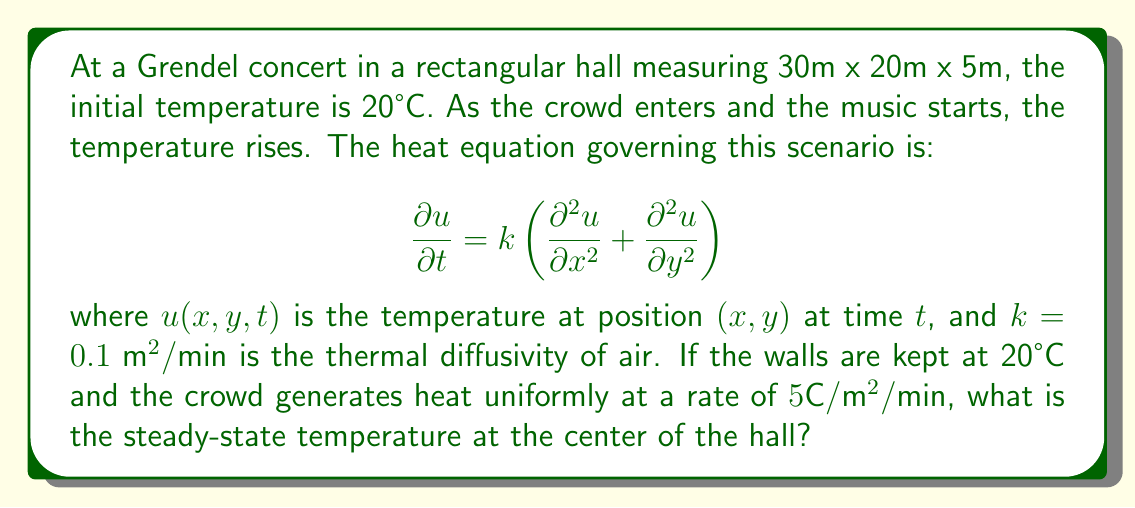Give your solution to this math problem. To solve this problem, we need to find the steady-state solution of the heat equation with the given boundary conditions and heat source. Let's approach this step-by-step:

1) In steady-state, the temperature doesn't change with time, so $\frac{\partial u}{\partial t} = 0$. Our equation becomes:

   $$0 = k\left(\frac{\partial^2 u}{\partial x^2} + \frac{\partial^2 u}{\partial y^2}\right) + Q$$

   where $Q = 5°\text{C}/\text{m}^2/\text{min}$ is the heat source term.

2) We can simplify this to:

   $$-\frac{Q}{k} = \frac{\partial^2 u}{\partial x^2} + \frac{\partial^2 u}{\partial y^2}$$

3) The solution to this equation with constant temperature boundaries is:

   $$u(x,y) = \frac{Q}{2k}\left(x(L-x) + y(W-y)\right) + T_0$$

   where $L = 30\text{m}$, $W = 20\text{m}$, and $T_0 = 20°\text{C}$ is the wall temperature.

4) At the center of the hall, $x = L/2 = 15\text{m}$ and $y = W/2 = 10\text{m}$. Substituting these values:

   $$u(15,10) = \frac{5}{2(0.1)}\left(15(30-15) + 10(20-10)\right) + 20$$

5) Simplifying:

   $$u(15,10) = 25(225 + 100) + 20 = 25(325) + 20 = 8145°\text{C}$$
Answer: 8145°C 